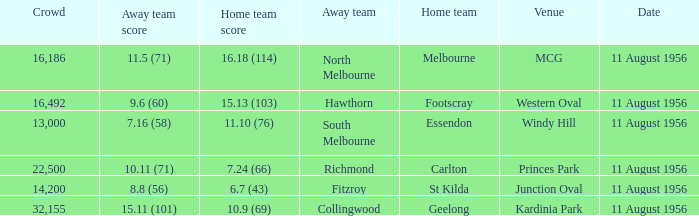Which home team possesses a score of 1 Melbourne. Could you parse the entire table as a dict? {'header': ['Crowd', 'Away team score', 'Home team score', 'Away team', 'Home team', 'Venue', 'Date'], 'rows': [['16,186', '11.5 (71)', '16.18 (114)', 'North Melbourne', 'Melbourne', 'MCG', '11 August 1956'], ['16,492', '9.6 (60)', '15.13 (103)', 'Hawthorn', 'Footscray', 'Western Oval', '11 August 1956'], ['13,000', '7.16 (58)', '11.10 (76)', 'South Melbourne', 'Essendon', 'Windy Hill', '11 August 1956'], ['22,500', '10.11 (71)', '7.24 (66)', 'Richmond', 'Carlton', 'Princes Park', '11 August 1956'], ['14,200', '8.8 (56)', '6.7 (43)', 'Fitzroy', 'St Kilda', 'Junction Oval', '11 August 1956'], ['32,155', '15.11 (101)', '10.9 (69)', 'Collingwood', 'Geelong', 'Kardinia Park', '11 August 1956']]} 